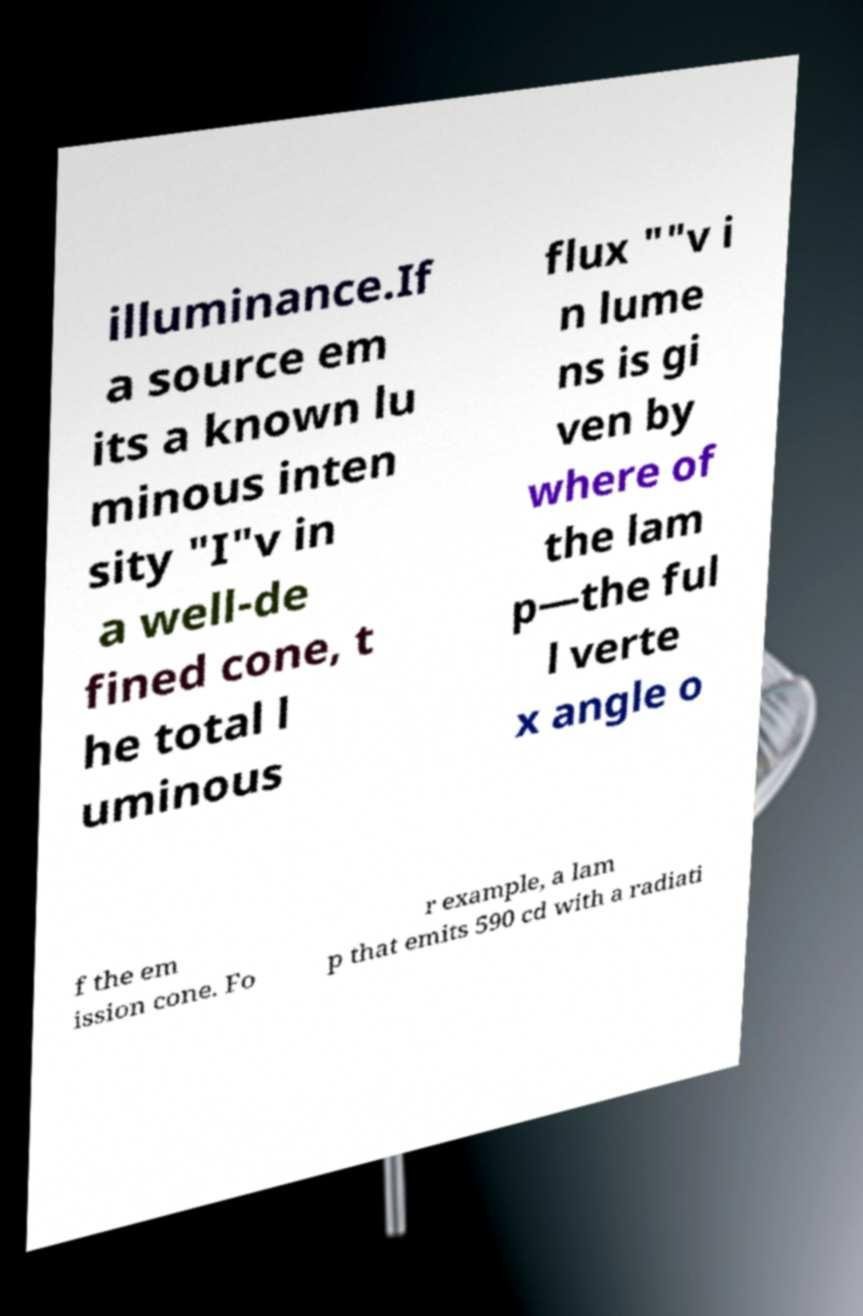There's text embedded in this image that I need extracted. Can you transcribe it verbatim? illuminance.If a source em its a known lu minous inten sity "I"v in a well-de fined cone, t he total l uminous flux ""v i n lume ns is gi ven by where of the lam p—the ful l verte x angle o f the em ission cone. Fo r example, a lam p that emits 590 cd with a radiati 